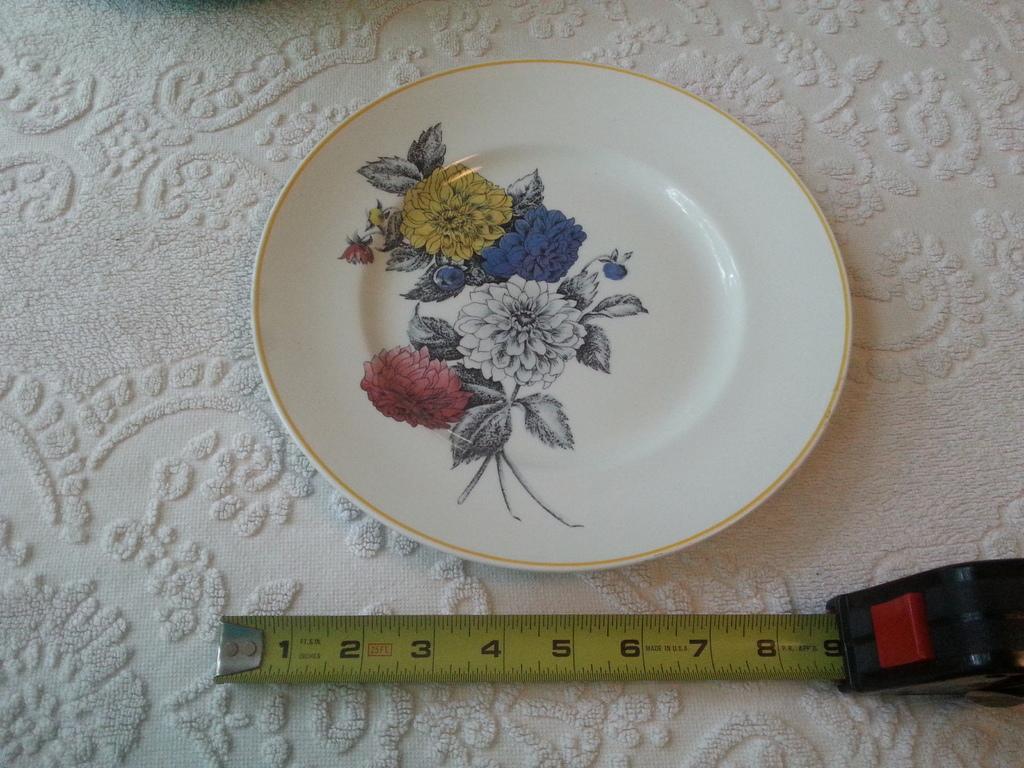Can you describe this image briefly? In this image on a table there is a plate. On the plate there is a print of flowers. Here there is a measuring tape. On the table there is a tablecloth. 